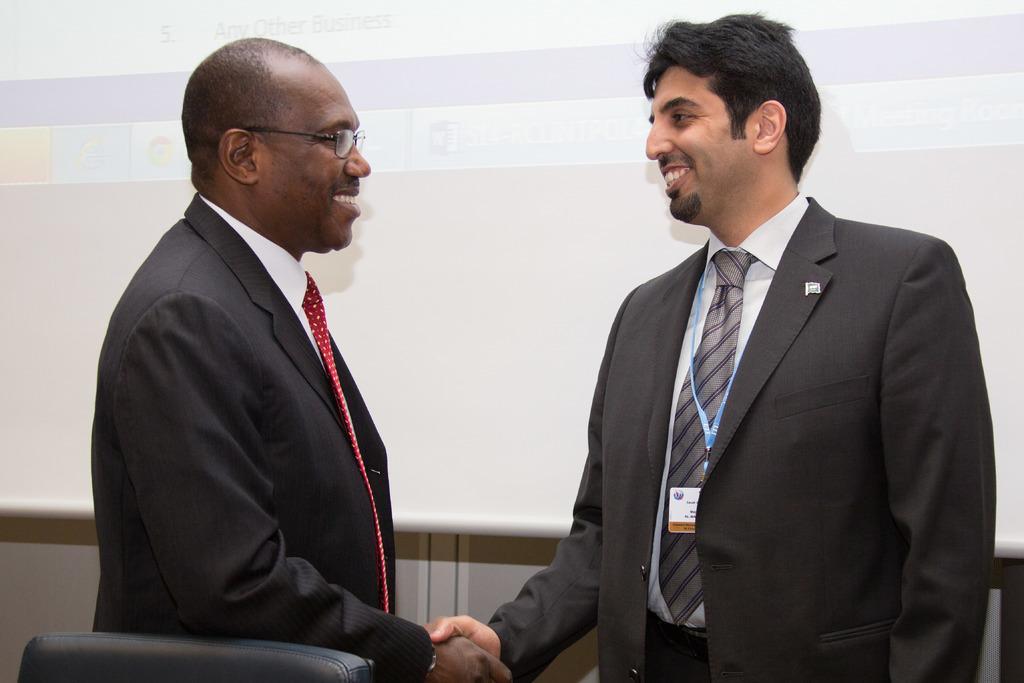Could you give a brief overview of what you see in this image? In this image we can see two men are standing and giving shake hands. In the background we can see screen and wall. At the bottom we can see a chair. 